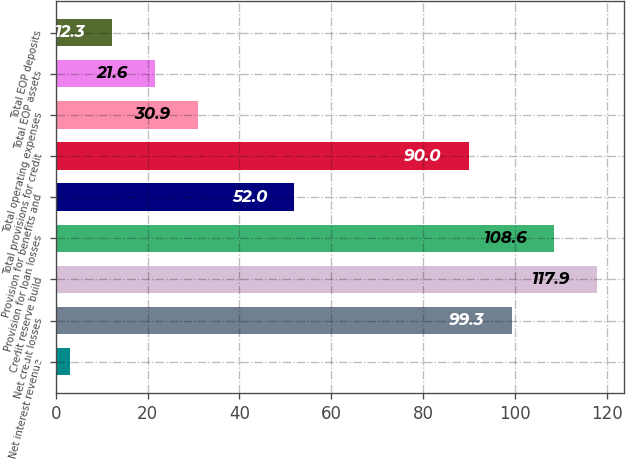Convert chart to OTSL. <chart><loc_0><loc_0><loc_500><loc_500><bar_chart><fcel>Net interest revenue<fcel>Net credit losses<fcel>Credit reserve build<fcel>Provision for loan losses<fcel>Provision for benefits and<fcel>Total provisions for credit<fcel>Total operating expenses<fcel>Total EOP assets<fcel>Total EOP deposits<nl><fcel>3<fcel>99.3<fcel>117.9<fcel>108.6<fcel>52<fcel>90<fcel>30.9<fcel>21.6<fcel>12.3<nl></chart> 